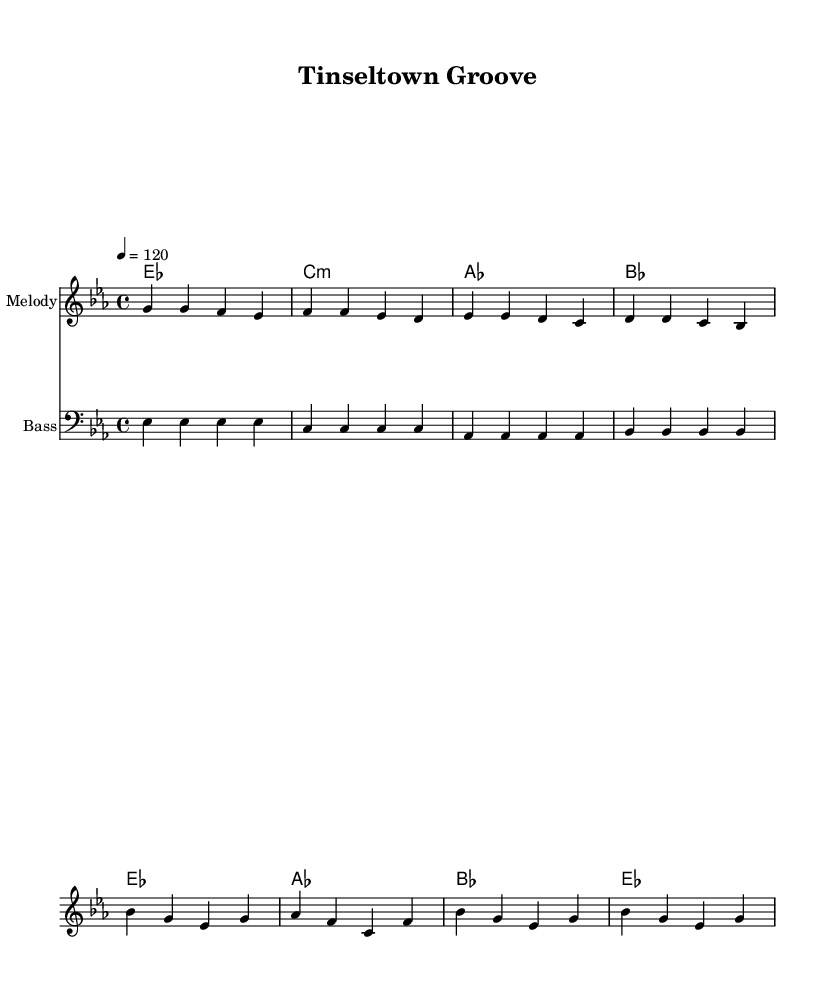What is the key signature of this music? The key signature indicates Es major, which contains three flats (B, E, and A). This can be identified in the sheet music where the flat symbols are placed at the beginning of the staff.
Answer: Es major What is the time signature of this composition? The time signature shown is 4/4, which is indicated at the beginning of the staff. This means there are four beats in each measure and the quarter note receives one beat.
Answer: 4/4 What is the tempo marking for this piece? The tempo marking is "4 = 120," meaning that each quarter note (4) is played at a rate of 120 beats per minute. This is specified in the tempo indication at the beginning of the score.
Answer: 120 How many measures are in the verse section? The verse consists of four measures, as indicated by the division of the musical staff into distinct segments, each representing a measure.
Answer: 4 What type of chords are used in the verse? The verse chords consist of Es major, C minor, A flat major, and B flat major, which can be observed in the chord symbols above the staff for the verse section.
Answer: Es, C:m, A, B What is the lyric theme for the chorus? The chorus lyrics revolve around the theme of glamour and shine, as reflected in the words "Golden age glamour, Hollywood shine," which is part of the lyrical text under the chorus section.
Answer: Glamour Which section features the line "Lights, camera, action" in the lyrics? This line appears in the verse, which is shown in the lyrics under the melody in the corresponding section, indicating the start of that text.
Answer: Verse 